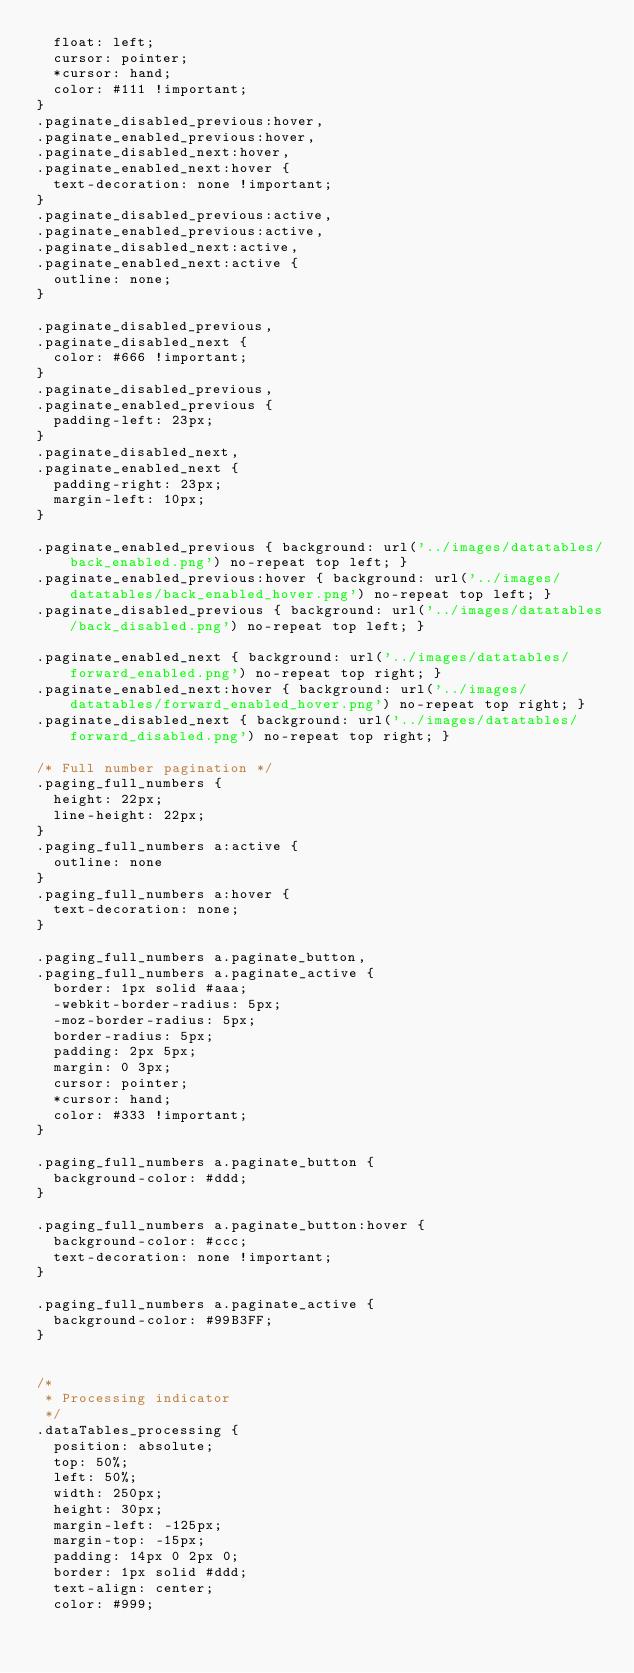<code> <loc_0><loc_0><loc_500><loc_500><_CSS_>	float: left;
	cursor: pointer;
	*cursor: hand;
	color: #111 !important;
}
.paginate_disabled_previous:hover,
.paginate_enabled_previous:hover,
.paginate_disabled_next:hover,
.paginate_enabled_next:hover {
	text-decoration: none !important;
}
.paginate_disabled_previous:active,
.paginate_enabled_previous:active,
.paginate_disabled_next:active,
.paginate_enabled_next:active {
	outline: none;
}

.paginate_disabled_previous,
.paginate_disabled_next {
	color: #666 !important;
}
.paginate_disabled_previous,
.paginate_enabled_previous {
	padding-left: 23px;
}
.paginate_disabled_next,
.paginate_enabled_next {
	padding-right: 23px;
	margin-left: 10px;
}

.paginate_enabled_previous { background: url('../images/datatables/back_enabled.png') no-repeat top left; }
.paginate_enabled_previous:hover { background: url('../images/datatables/back_enabled_hover.png') no-repeat top left; }
.paginate_disabled_previous { background: url('../images/datatables/back_disabled.png') no-repeat top left; }

.paginate_enabled_next { background: url('../images/datatables/forward_enabled.png') no-repeat top right; }
.paginate_enabled_next:hover { background: url('../images/datatables/forward_enabled_hover.png') no-repeat top right; }
.paginate_disabled_next { background: url('../images/datatables/forward_disabled.png') no-repeat top right; }

/* Full number pagination */
.paging_full_numbers {
	height: 22px;
	line-height: 22px;
}
.paging_full_numbers a:active {
	outline: none
}
.paging_full_numbers a:hover {
	text-decoration: none;
}

.paging_full_numbers a.paginate_button,
.paging_full_numbers a.paginate_active {
	border: 1px solid #aaa;
	-webkit-border-radius: 5px;
	-moz-border-radius: 5px;
	border-radius: 5px;
	padding: 2px 5px;
	margin: 0 3px;
	cursor: pointer;
	*cursor: hand;
	color: #333 !important;
}

.paging_full_numbers a.paginate_button {
	background-color: #ddd;
}

.paging_full_numbers a.paginate_button:hover {
	background-color: #ccc;
	text-decoration: none !important;
}

.paging_full_numbers a.paginate_active {
	background-color: #99B3FF;
}


/*
 * Processing indicator
 */
.dataTables_processing {
	position: absolute;
	top: 50%;
	left: 50%;
	width: 250px;
	height: 30px;
	margin-left: -125px;
	margin-top: -15px;
	padding: 14px 0 2px 0;
	border: 1px solid #ddd;
	text-align: center;
	color: #999;</code> 